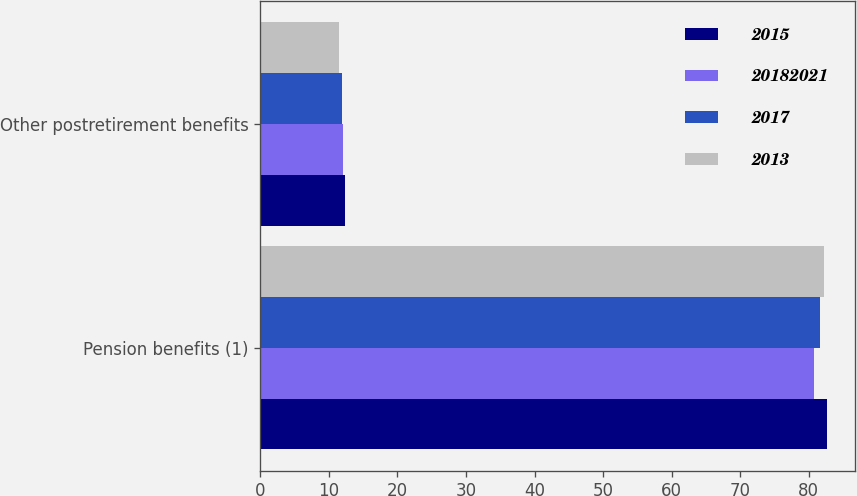<chart> <loc_0><loc_0><loc_500><loc_500><stacked_bar_chart><ecel><fcel>Pension benefits (1)<fcel>Other postretirement benefits<nl><fcel>2015<fcel>82.6<fcel>12.4<nl><fcel>2.0182e+07<fcel>80.7<fcel>12.1<nl><fcel>2017<fcel>81.6<fcel>11.9<nl><fcel>2013<fcel>82.2<fcel>11.5<nl></chart> 